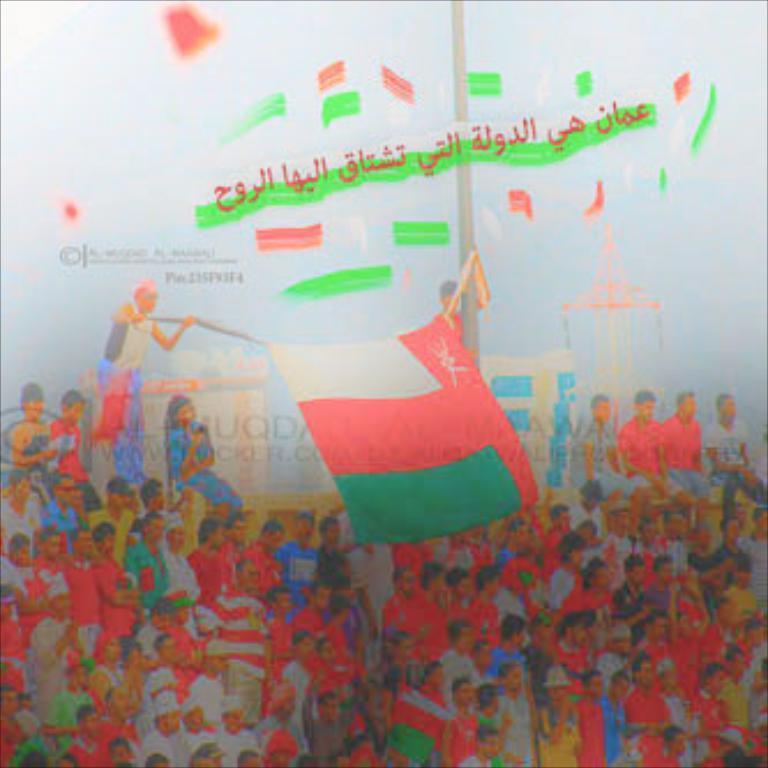Can you describe this image briefly? In this image we can see people standing. There is text at the center of the image. There is a flag. At the top of the image there is some text. 